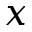Convert formula to latex. <formula><loc_0><loc_0><loc_500><loc_500>x</formula> 